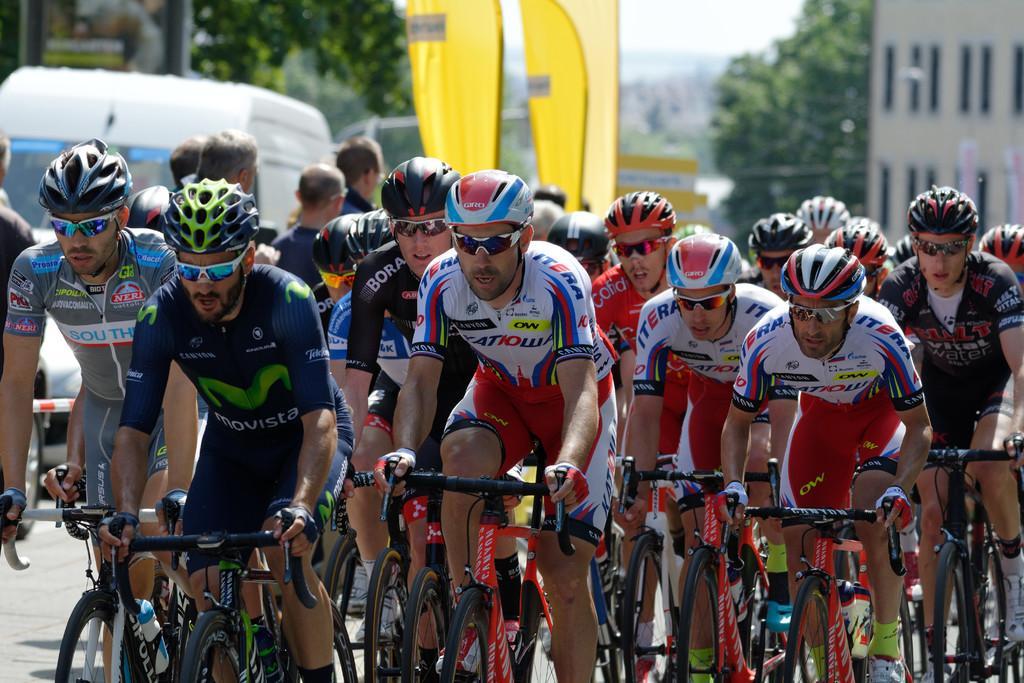Describe this image in one or two sentences. In this image a group of persons riding bicycles, in the background there are trees, buildings and vehicles are moving on the road. 